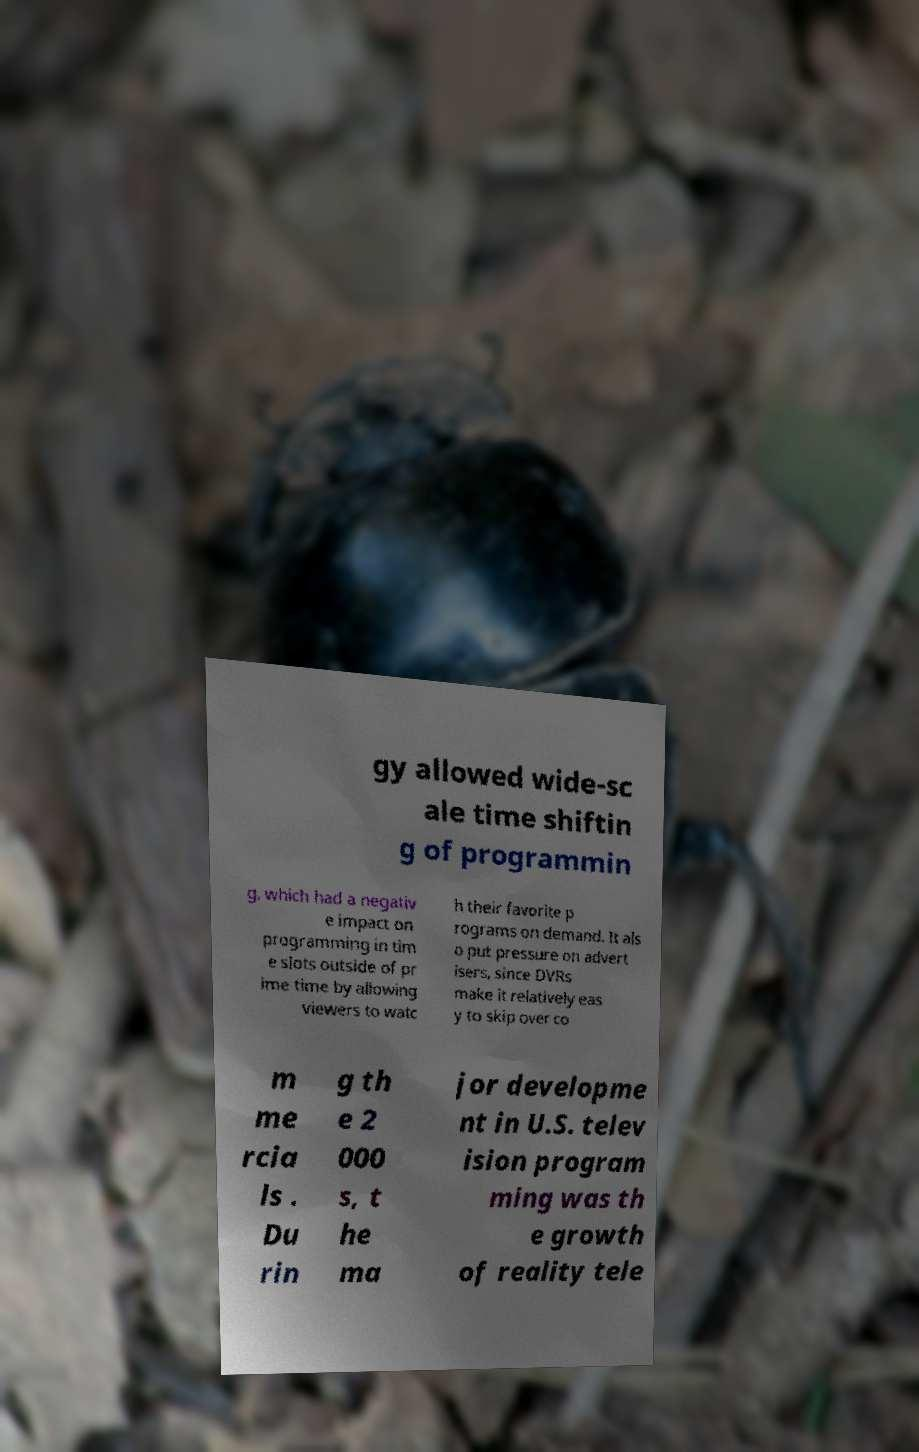What messages or text are displayed in this image? I need them in a readable, typed format. gy allowed wide-sc ale time shiftin g of programmin g, which had a negativ e impact on programming in tim e slots outside of pr ime time by allowing viewers to watc h their favorite p rograms on demand. It als o put pressure on advert isers, since DVRs make it relatively eas y to skip over co m me rcia ls . Du rin g th e 2 000 s, t he ma jor developme nt in U.S. telev ision program ming was th e growth of reality tele 